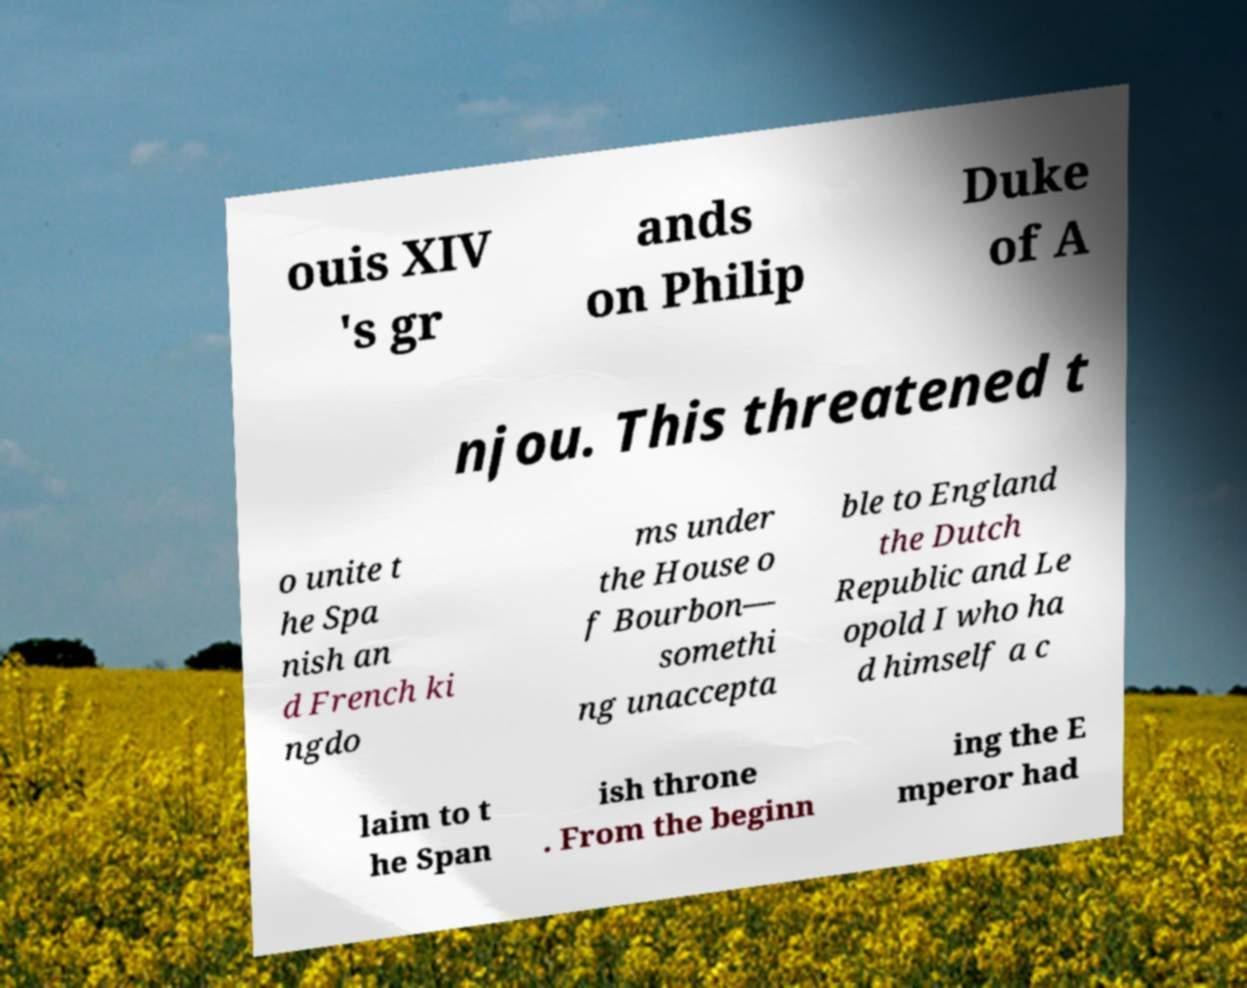Could you extract and type out the text from this image? ouis XIV 's gr ands on Philip Duke of A njou. This threatened t o unite t he Spa nish an d French ki ngdo ms under the House o f Bourbon— somethi ng unaccepta ble to England the Dutch Republic and Le opold I who ha d himself a c laim to t he Span ish throne . From the beginn ing the E mperor had 